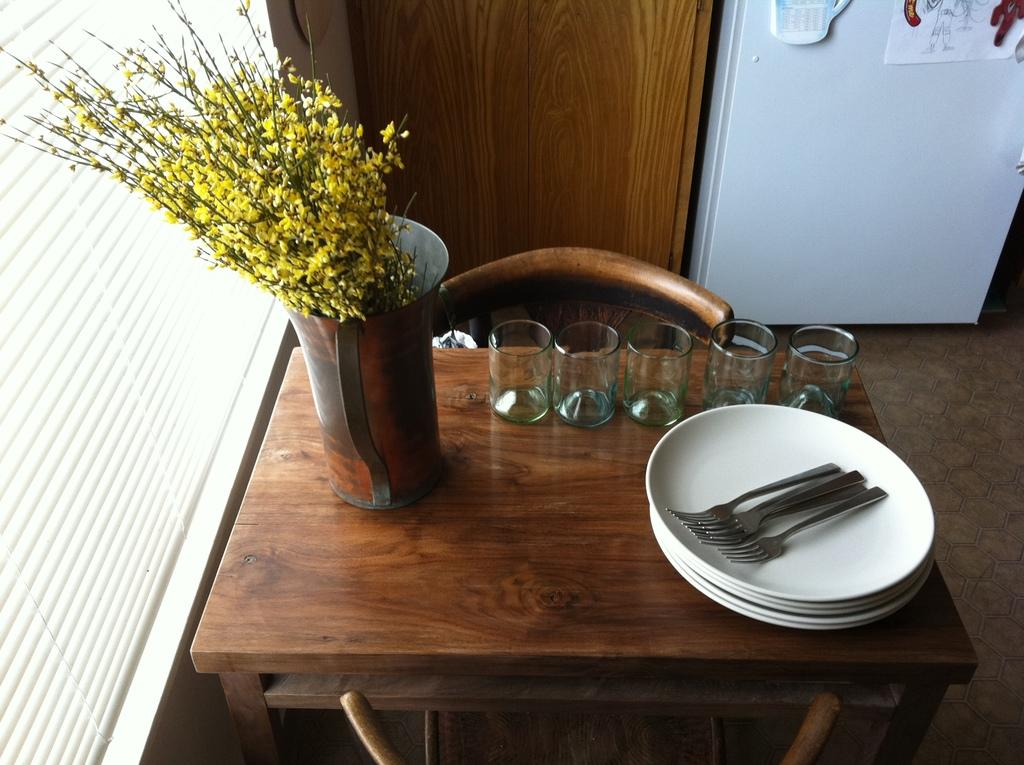What type of furniture is present in the image? There is a table in the image. What items can be seen on the table? There are glasses, plates, spoons, and a flower vase on the table. What might be used for drinking in the image? The glasses on the table might be used for drinking. What might be used for holding flowers in the image? The flower vase on the table might be used for holding flowers. What is the name of the daughter in the image? There is no daughter present in the image. What thoughts are expressed by the objects in the image? The objects in the image do not express thoughts; they are inanimate. 